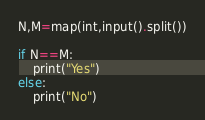<code> <loc_0><loc_0><loc_500><loc_500><_Python_>N,M=map(int,input().split())

if N==M:
    print("Yes")
else:
    print("No")</code> 